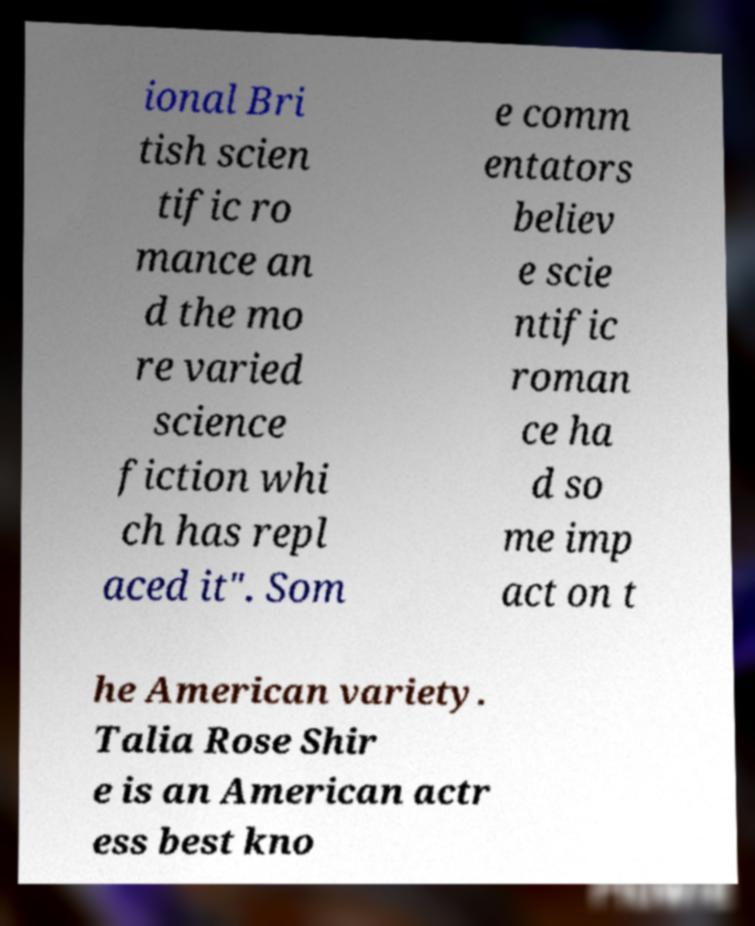There's text embedded in this image that I need extracted. Can you transcribe it verbatim? ional Bri tish scien tific ro mance an d the mo re varied science fiction whi ch has repl aced it". Som e comm entators believ e scie ntific roman ce ha d so me imp act on t he American variety. Talia Rose Shir e is an American actr ess best kno 